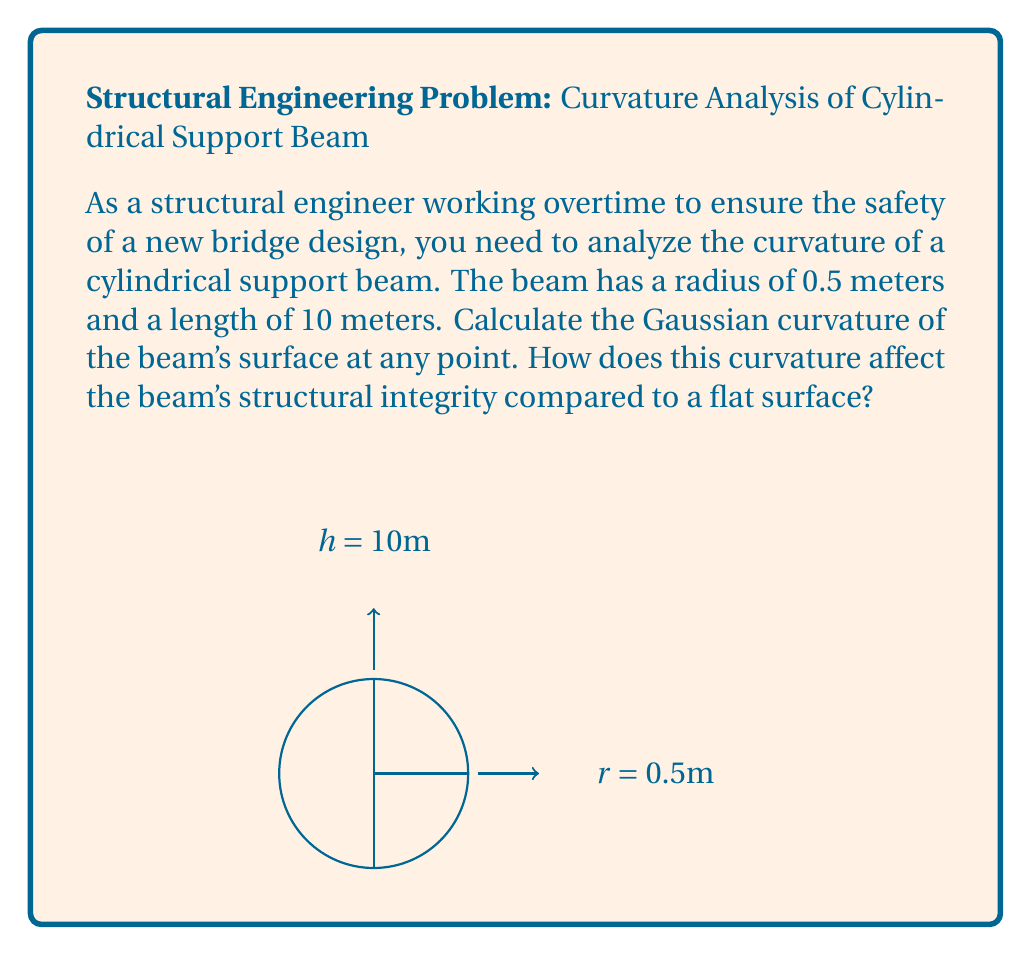Help me with this question. Let's approach this step-by-step:

1) For a cylindrical surface, we need to consider its principal curvatures:

   - The curvature along the length of the cylinder (axial direction) is zero.
   - The curvature in the circular cross-section is the reciprocal of the radius.

2) The Gaussian curvature (K) is the product of these two principal curvatures:

   $$K = k_1 \cdot k_2$$

   where $k_1$ and $k_2$ are the principal curvatures.

3) In this case:
   $k_1 = 0$ (axial direction)
   $k_2 = \frac{1}{r} = \frac{1}{0.5} = 2$ (circular cross-section)

4) Therefore, the Gaussian curvature is:

   $$K = 0 \cdot 2 = 0$$

5) The Gaussian curvature being zero indicates that the surface is developable, meaning it can be flattened onto a plane without distortion.

6) Regarding structural integrity:
   - The non-zero curvature in one direction (circular cross-section) provides better resistance to bending and buckling compared to a flat surface.
   - The zero curvature along the length allows for even distribution of axial loads.
   - This combination of curvatures makes cylindrical beams efficient for load-bearing in many engineering applications, offering a good balance between strength and material usage.
Answer: Gaussian curvature: $K = 0$. Improved structural integrity due to non-zero curvature in circular cross-section. 